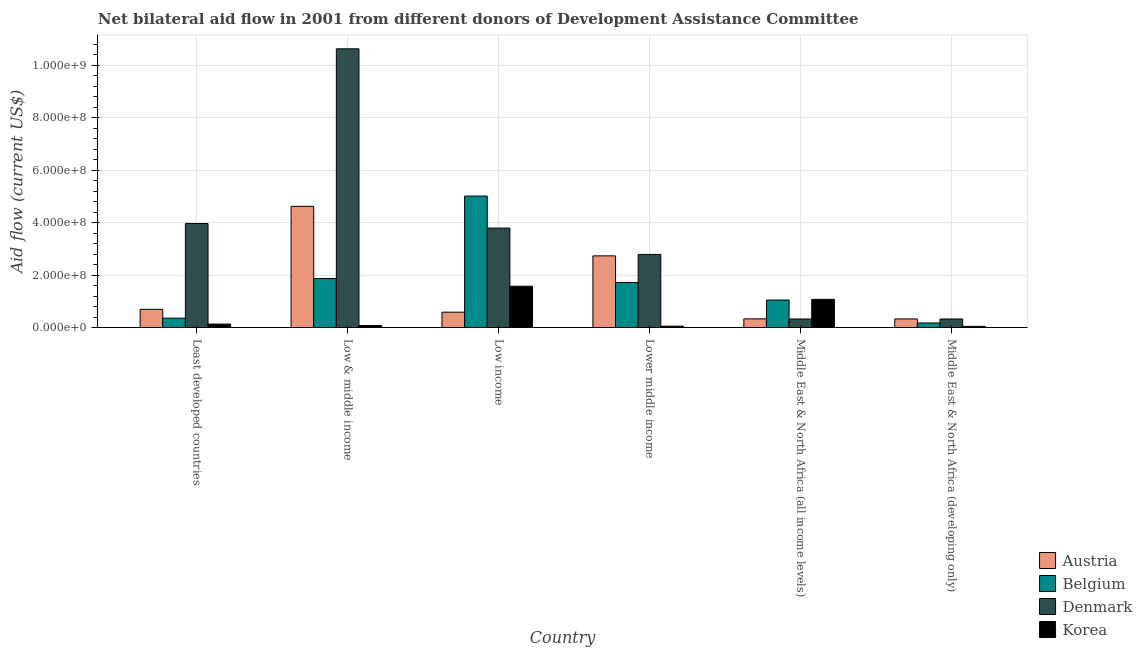How many different coloured bars are there?
Offer a very short reply. 4. How many groups of bars are there?
Your response must be concise. 6. Are the number of bars per tick equal to the number of legend labels?
Offer a terse response. Yes. How many bars are there on the 4th tick from the right?
Provide a succinct answer. 4. What is the label of the 6th group of bars from the left?
Offer a terse response. Middle East & North Africa (developing only). What is the amount of aid given by austria in Low income?
Provide a short and direct response. 5.91e+07. Across all countries, what is the maximum amount of aid given by denmark?
Ensure brevity in your answer.  1.06e+09. Across all countries, what is the minimum amount of aid given by belgium?
Your response must be concise. 1.79e+07. In which country was the amount of aid given by austria maximum?
Provide a succinct answer. Low & middle income. In which country was the amount of aid given by denmark minimum?
Give a very brief answer. Middle East & North Africa (all income levels). What is the total amount of aid given by belgium in the graph?
Your answer should be compact. 1.02e+09. What is the difference between the amount of aid given by korea in Least developed countries and that in Middle East & North Africa (all income levels)?
Provide a short and direct response. -9.42e+07. What is the difference between the amount of aid given by korea in Lower middle income and the amount of aid given by denmark in Least developed countries?
Your response must be concise. -3.91e+08. What is the average amount of aid given by austria per country?
Offer a terse response. 1.55e+08. What is the difference between the amount of aid given by denmark and amount of aid given by austria in Middle East & North Africa (all income levels)?
Ensure brevity in your answer.  -4.50e+05. In how many countries, is the amount of aid given by belgium greater than 40000000 US$?
Offer a terse response. 4. What is the ratio of the amount of aid given by austria in Least developed countries to that in Middle East & North Africa (developing only)?
Keep it short and to the point. 2.1. Is the difference between the amount of aid given by korea in Least developed countries and Middle East & North Africa (developing only) greater than the difference between the amount of aid given by belgium in Least developed countries and Middle East & North Africa (developing only)?
Give a very brief answer. No. What is the difference between the highest and the second highest amount of aid given by korea?
Your answer should be very brief. 5.00e+07. What is the difference between the highest and the lowest amount of aid given by belgium?
Your answer should be compact. 4.84e+08. Is it the case that in every country, the sum of the amount of aid given by korea and amount of aid given by denmark is greater than the sum of amount of aid given by austria and amount of aid given by belgium?
Offer a terse response. No. Are all the bars in the graph horizontal?
Ensure brevity in your answer.  No. How many countries are there in the graph?
Your answer should be compact. 6. What is the difference between two consecutive major ticks on the Y-axis?
Keep it short and to the point. 2.00e+08. Does the graph contain any zero values?
Ensure brevity in your answer.  No. Does the graph contain grids?
Provide a short and direct response. Yes. Where does the legend appear in the graph?
Give a very brief answer. Bottom right. How many legend labels are there?
Your answer should be compact. 4. How are the legend labels stacked?
Offer a terse response. Vertical. What is the title of the graph?
Your response must be concise. Net bilateral aid flow in 2001 from different donors of Development Assistance Committee. What is the label or title of the Y-axis?
Offer a terse response. Aid flow (current US$). What is the Aid flow (current US$) of Austria in Least developed countries?
Keep it short and to the point. 6.99e+07. What is the Aid flow (current US$) of Belgium in Least developed countries?
Your response must be concise. 3.63e+07. What is the Aid flow (current US$) of Denmark in Least developed countries?
Provide a short and direct response. 3.97e+08. What is the Aid flow (current US$) in Korea in Least developed countries?
Your answer should be very brief. 1.37e+07. What is the Aid flow (current US$) of Austria in Low & middle income?
Keep it short and to the point. 4.62e+08. What is the Aid flow (current US$) of Belgium in Low & middle income?
Ensure brevity in your answer.  1.87e+08. What is the Aid flow (current US$) in Denmark in Low & middle income?
Make the answer very short. 1.06e+09. What is the Aid flow (current US$) of Korea in Low & middle income?
Your answer should be very brief. 8.23e+06. What is the Aid flow (current US$) of Austria in Low income?
Keep it short and to the point. 5.91e+07. What is the Aid flow (current US$) of Belgium in Low income?
Ensure brevity in your answer.  5.02e+08. What is the Aid flow (current US$) of Denmark in Low income?
Keep it short and to the point. 3.80e+08. What is the Aid flow (current US$) of Korea in Low income?
Keep it short and to the point. 1.58e+08. What is the Aid flow (current US$) of Austria in Lower middle income?
Your answer should be compact. 2.74e+08. What is the Aid flow (current US$) in Belgium in Lower middle income?
Your response must be concise. 1.72e+08. What is the Aid flow (current US$) in Denmark in Lower middle income?
Offer a very short reply. 2.79e+08. What is the Aid flow (current US$) of Korea in Lower middle income?
Provide a succinct answer. 5.68e+06. What is the Aid flow (current US$) of Austria in Middle East & North Africa (all income levels)?
Your response must be concise. 3.35e+07. What is the Aid flow (current US$) in Belgium in Middle East & North Africa (all income levels)?
Make the answer very short. 1.05e+08. What is the Aid flow (current US$) of Denmark in Middle East & North Africa (all income levels)?
Keep it short and to the point. 3.31e+07. What is the Aid flow (current US$) in Korea in Middle East & North Africa (all income levels)?
Give a very brief answer. 1.08e+08. What is the Aid flow (current US$) of Austria in Middle East & North Africa (developing only)?
Give a very brief answer. 3.33e+07. What is the Aid flow (current US$) in Belgium in Middle East & North Africa (developing only)?
Make the answer very short. 1.79e+07. What is the Aid flow (current US$) of Denmark in Middle East & North Africa (developing only)?
Your answer should be very brief. 3.31e+07. What is the Aid flow (current US$) of Korea in Middle East & North Africa (developing only)?
Provide a succinct answer. 4.88e+06. Across all countries, what is the maximum Aid flow (current US$) of Austria?
Ensure brevity in your answer.  4.62e+08. Across all countries, what is the maximum Aid flow (current US$) in Belgium?
Provide a succinct answer. 5.02e+08. Across all countries, what is the maximum Aid flow (current US$) of Denmark?
Your answer should be very brief. 1.06e+09. Across all countries, what is the maximum Aid flow (current US$) in Korea?
Ensure brevity in your answer.  1.58e+08. Across all countries, what is the minimum Aid flow (current US$) of Austria?
Give a very brief answer. 3.33e+07. Across all countries, what is the minimum Aid flow (current US$) in Belgium?
Your answer should be compact. 1.79e+07. Across all countries, what is the minimum Aid flow (current US$) in Denmark?
Make the answer very short. 3.31e+07. Across all countries, what is the minimum Aid flow (current US$) in Korea?
Give a very brief answer. 4.88e+06. What is the total Aid flow (current US$) in Austria in the graph?
Keep it short and to the point. 9.32e+08. What is the total Aid flow (current US$) of Belgium in the graph?
Keep it short and to the point. 1.02e+09. What is the total Aid flow (current US$) in Denmark in the graph?
Keep it short and to the point. 2.18e+09. What is the total Aid flow (current US$) of Korea in the graph?
Your response must be concise. 2.98e+08. What is the difference between the Aid flow (current US$) of Austria in Least developed countries and that in Low & middle income?
Offer a terse response. -3.93e+08. What is the difference between the Aid flow (current US$) in Belgium in Least developed countries and that in Low & middle income?
Provide a succinct answer. -1.51e+08. What is the difference between the Aid flow (current US$) in Denmark in Least developed countries and that in Low & middle income?
Make the answer very short. -6.66e+08. What is the difference between the Aid flow (current US$) of Korea in Least developed countries and that in Low & middle income?
Your answer should be very brief. 5.43e+06. What is the difference between the Aid flow (current US$) of Austria in Least developed countries and that in Low income?
Make the answer very short. 1.08e+07. What is the difference between the Aid flow (current US$) of Belgium in Least developed countries and that in Low income?
Ensure brevity in your answer.  -4.65e+08. What is the difference between the Aid flow (current US$) in Denmark in Least developed countries and that in Low income?
Make the answer very short. 1.73e+07. What is the difference between the Aid flow (current US$) of Korea in Least developed countries and that in Low income?
Keep it short and to the point. -1.44e+08. What is the difference between the Aid flow (current US$) of Austria in Least developed countries and that in Lower middle income?
Provide a succinct answer. -2.04e+08. What is the difference between the Aid flow (current US$) in Belgium in Least developed countries and that in Lower middle income?
Your answer should be compact. -1.36e+08. What is the difference between the Aid flow (current US$) in Denmark in Least developed countries and that in Lower middle income?
Ensure brevity in your answer.  1.18e+08. What is the difference between the Aid flow (current US$) of Korea in Least developed countries and that in Lower middle income?
Make the answer very short. 7.98e+06. What is the difference between the Aid flow (current US$) of Austria in Least developed countries and that in Middle East & North Africa (all income levels)?
Provide a short and direct response. 3.64e+07. What is the difference between the Aid flow (current US$) in Belgium in Least developed countries and that in Middle East & North Africa (all income levels)?
Make the answer very short. -6.90e+07. What is the difference between the Aid flow (current US$) of Denmark in Least developed countries and that in Middle East & North Africa (all income levels)?
Your answer should be compact. 3.64e+08. What is the difference between the Aid flow (current US$) in Korea in Least developed countries and that in Middle East & North Africa (all income levels)?
Your response must be concise. -9.42e+07. What is the difference between the Aid flow (current US$) of Austria in Least developed countries and that in Middle East & North Africa (developing only)?
Your answer should be very brief. 3.66e+07. What is the difference between the Aid flow (current US$) of Belgium in Least developed countries and that in Middle East & North Africa (developing only)?
Give a very brief answer. 1.84e+07. What is the difference between the Aid flow (current US$) in Denmark in Least developed countries and that in Middle East & North Africa (developing only)?
Provide a succinct answer. 3.64e+08. What is the difference between the Aid flow (current US$) of Korea in Least developed countries and that in Middle East & North Africa (developing only)?
Offer a terse response. 8.78e+06. What is the difference between the Aid flow (current US$) of Austria in Low & middle income and that in Low income?
Give a very brief answer. 4.03e+08. What is the difference between the Aid flow (current US$) of Belgium in Low & middle income and that in Low income?
Give a very brief answer. -3.14e+08. What is the difference between the Aid flow (current US$) in Denmark in Low & middle income and that in Low income?
Provide a short and direct response. 6.83e+08. What is the difference between the Aid flow (current US$) in Korea in Low & middle income and that in Low income?
Offer a terse response. -1.50e+08. What is the difference between the Aid flow (current US$) of Austria in Low & middle income and that in Lower middle income?
Your response must be concise. 1.89e+08. What is the difference between the Aid flow (current US$) of Belgium in Low & middle income and that in Lower middle income?
Make the answer very short. 1.51e+07. What is the difference between the Aid flow (current US$) of Denmark in Low & middle income and that in Lower middle income?
Provide a short and direct response. 7.84e+08. What is the difference between the Aid flow (current US$) of Korea in Low & middle income and that in Lower middle income?
Offer a very short reply. 2.55e+06. What is the difference between the Aid flow (current US$) of Austria in Low & middle income and that in Middle East & North Africa (all income levels)?
Provide a short and direct response. 4.29e+08. What is the difference between the Aid flow (current US$) of Belgium in Low & middle income and that in Middle East & North Africa (all income levels)?
Make the answer very short. 8.21e+07. What is the difference between the Aid flow (current US$) of Denmark in Low & middle income and that in Middle East & North Africa (all income levels)?
Keep it short and to the point. 1.03e+09. What is the difference between the Aid flow (current US$) of Korea in Low & middle income and that in Middle East & North Africa (all income levels)?
Make the answer very short. -9.96e+07. What is the difference between the Aid flow (current US$) in Austria in Low & middle income and that in Middle East & North Africa (developing only)?
Your answer should be very brief. 4.29e+08. What is the difference between the Aid flow (current US$) in Belgium in Low & middle income and that in Middle East & North Africa (developing only)?
Your response must be concise. 1.69e+08. What is the difference between the Aid flow (current US$) in Denmark in Low & middle income and that in Middle East & North Africa (developing only)?
Keep it short and to the point. 1.03e+09. What is the difference between the Aid flow (current US$) of Korea in Low & middle income and that in Middle East & North Africa (developing only)?
Offer a terse response. 3.35e+06. What is the difference between the Aid flow (current US$) of Austria in Low income and that in Lower middle income?
Your response must be concise. -2.15e+08. What is the difference between the Aid flow (current US$) of Belgium in Low income and that in Lower middle income?
Provide a succinct answer. 3.29e+08. What is the difference between the Aid flow (current US$) of Denmark in Low income and that in Lower middle income?
Make the answer very short. 1.01e+08. What is the difference between the Aid flow (current US$) in Korea in Low income and that in Lower middle income?
Your answer should be compact. 1.52e+08. What is the difference between the Aid flow (current US$) in Austria in Low income and that in Middle East & North Africa (all income levels)?
Ensure brevity in your answer.  2.56e+07. What is the difference between the Aid flow (current US$) in Belgium in Low income and that in Middle East & North Africa (all income levels)?
Give a very brief answer. 3.96e+08. What is the difference between the Aid flow (current US$) in Denmark in Low income and that in Middle East & North Africa (all income levels)?
Offer a very short reply. 3.47e+08. What is the difference between the Aid flow (current US$) of Korea in Low income and that in Middle East & North Africa (all income levels)?
Provide a short and direct response. 5.00e+07. What is the difference between the Aid flow (current US$) of Austria in Low income and that in Middle East & North Africa (developing only)?
Offer a very short reply. 2.58e+07. What is the difference between the Aid flow (current US$) in Belgium in Low income and that in Middle East & North Africa (developing only)?
Ensure brevity in your answer.  4.84e+08. What is the difference between the Aid flow (current US$) in Denmark in Low income and that in Middle East & North Africa (developing only)?
Keep it short and to the point. 3.47e+08. What is the difference between the Aid flow (current US$) of Korea in Low income and that in Middle East & North Africa (developing only)?
Offer a terse response. 1.53e+08. What is the difference between the Aid flow (current US$) in Austria in Lower middle income and that in Middle East & North Africa (all income levels)?
Make the answer very short. 2.40e+08. What is the difference between the Aid flow (current US$) in Belgium in Lower middle income and that in Middle East & North Africa (all income levels)?
Your response must be concise. 6.70e+07. What is the difference between the Aid flow (current US$) in Denmark in Lower middle income and that in Middle East & North Africa (all income levels)?
Your answer should be compact. 2.46e+08. What is the difference between the Aid flow (current US$) of Korea in Lower middle income and that in Middle East & North Africa (all income levels)?
Ensure brevity in your answer.  -1.02e+08. What is the difference between the Aid flow (current US$) of Austria in Lower middle income and that in Middle East & North Africa (developing only)?
Offer a terse response. 2.40e+08. What is the difference between the Aid flow (current US$) in Belgium in Lower middle income and that in Middle East & North Africa (developing only)?
Your answer should be compact. 1.54e+08. What is the difference between the Aid flow (current US$) of Denmark in Lower middle income and that in Middle East & North Africa (developing only)?
Provide a succinct answer. 2.46e+08. What is the difference between the Aid flow (current US$) of Korea in Lower middle income and that in Middle East & North Africa (developing only)?
Offer a very short reply. 8.00e+05. What is the difference between the Aid flow (current US$) in Belgium in Middle East & North Africa (all income levels) and that in Middle East & North Africa (developing only)?
Provide a short and direct response. 8.74e+07. What is the difference between the Aid flow (current US$) of Korea in Middle East & North Africa (all income levels) and that in Middle East & North Africa (developing only)?
Ensure brevity in your answer.  1.03e+08. What is the difference between the Aid flow (current US$) of Austria in Least developed countries and the Aid flow (current US$) of Belgium in Low & middle income?
Provide a succinct answer. -1.18e+08. What is the difference between the Aid flow (current US$) of Austria in Least developed countries and the Aid flow (current US$) of Denmark in Low & middle income?
Make the answer very short. -9.93e+08. What is the difference between the Aid flow (current US$) in Austria in Least developed countries and the Aid flow (current US$) in Korea in Low & middle income?
Offer a very short reply. 6.17e+07. What is the difference between the Aid flow (current US$) of Belgium in Least developed countries and the Aid flow (current US$) of Denmark in Low & middle income?
Ensure brevity in your answer.  -1.03e+09. What is the difference between the Aid flow (current US$) of Belgium in Least developed countries and the Aid flow (current US$) of Korea in Low & middle income?
Offer a terse response. 2.81e+07. What is the difference between the Aid flow (current US$) in Denmark in Least developed countries and the Aid flow (current US$) in Korea in Low & middle income?
Offer a very short reply. 3.89e+08. What is the difference between the Aid flow (current US$) in Austria in Least developed countries and the Aid flow (current US$) in Belgium in Low income?
Offer a terse response. -4.32e+08. What is the difference between the Aid flow (current US$) of Austria in Least developed countries and the Aid flow (current US$) of Denmark in Low income?
Offer a very short reply. -3.10e+08. What is the difference between the Aid flow (current US$) in Austria in Least developed countries and the Aid flow (current US$) in Korea in Low income?
Your answer should be compact. -8.80e+07. What is the difference between the Aid flow (current US$) of Belgium in Least developed countries and the Aid flow (current US$) of Denmark in Low income?
Provide a succinct answer. -3.43e+08. What is the difference between the Aid flow (current US$) in Belgium in Least developed countries and the Aid flow (current US$) in Korea in Low income?
Make the answer very short. -1.22e+08. What is the difference between the Aid flow (current US$) in Denmark in Least developed countries and the Aid flow (current US$) in Korea in Low income?
Provide a short and direct response. 2.39e+08. What is the difference between the Aid flow (current US$) of Austria in Least developed countries and the Aid flow (current US$) of Belgium in Lower middle income?
Make the answer very short. -1.02e+08. What is the difference between the Aid flow (current US$) in Austria in Least developed countries and the Aid flow (current US$) in Denmark in Lower middle income?
Your answer should be very brief. -2.09e+08. What is the difference between the Aid flow (current US$) of Austria in Least developed countries and the Aid flow (current US$) of Korea in Lower middle income?
Provide a succinct answer. 6.42e+07. What is the difference between the Aid flow (current US$) of Belgium in Least developed countries and the Aid flow (current US$) of Denmark in Lower middle income?
Give a very brief answer. -2.43e+08. What is the difference between the Aid flow (current US$) of Belgium in Least developed countries and the Aid flow (current US$) of Korea in Lower middle income?
Provide a short and direct response. 3.07e+07. What is the difference between the Aid flow (current US$) in Denmark in Least developed countries and the Aid flow (current US$) in Korea in Lower middle income?
Keep it short and to the point. 3.91e+08. What is the difference between the Aid flow (current US$) in Austria in Least developed countries and the Aid flow (current US$) in Belgium in Middle East & North Africa (all income levels)?
Offer a very short reply. -3.54e+07. What is the difference between the Aid flow (current US$) in Austria in Least developed countries and the Aid flow (current US$) in Denmark in Middle East & North Africa (all income levels)?
Your answer should be compact. 3.68e+07. What is the difference between the Aid flow (current US$) in Austria in Least developed countries and the Aid flow (current US$) in Korea in Middle East & North Africa (all income levels)?
Provide a short and direct response. -3.80e+07. What is the difference between the Aid flow (current US$) of Belgium in Least developed countries and the Aid flow (current US$) of Denmark in Middle East & North Africa (all income levels)?
Offer a very short reply. 3.28e+06. What is the difference between the Aid flow (current US$) in Belgium in Least developed countries and the Aid flow (current US$) in Korea in Middle East & North Africa (all income levels)?
Give a very brief answer. -7.15e+07. What is the difference between the Aid flow (current US$) of Denmark in Least developed countries and the Aid flow (current US$) of Korea in Middle East & North Africa (all income levels)?
Provide a succinct answer. 2.89e+08. What is the difference between the Aid flow (current US$) of Austria in Least developed countries and the Aid flow (current US$) of Belgium in Middle East & North Africa (developing only)?
Keep it short and to the point. 5.20e+07. What is the difference between the Aid flow (current US$) of Austria in Least developed countries and the Aid flow (current US$) of Denmark in Middle East & North Africa (developing only)?
Your answer should be compact. 3.68e+07. What is the difference between the Aid flow (current US$) of Austria in Least developed countries and the Aid flow (current US$) of Korea in Middle East & North Africa (developing only)?
Make the answer very short. 6.50e+07. What is the difference between the Aid flow (current US$) of Belgium in Least developed countries and the Aid flow (current US$) of Denmark in Middle East & North Africa (developing only)?
Make the answer very short. 3.28e+06. What is the difference between the Aid flow (current US$) in Belgium in Least developed countries and the Aid flow (current US$) in Korea in Middle East & North Africa (developing only)?
Your answer should be very brief. 3.15e+07. What is the difference between the Aid flow (current US$) of Denmark in Least developed countries and the Aid flow (current US$) of Korea in Middle East & North Africa (developing only)?
Offer a very short reply. 3.92e+08. What is the difference between the Aid flow (current US$) in Austria in Low & middle income and the Aid flow (current US$) in Belgium in Low income?
Provide a succinct answer. -3.92e+07. What is the difference between the Aid flow (current US$) of Austria in Low & middle income and the Aid flow (current US$) of Denmark in Low income?
Provide a succinct answer. 8.28e+07. What is the difference between the Aid flow (current US$) in Austria in Low & middle income and the Aid flow (current US$) in Korea in Low income?
Make the answer very short. 3.04e+08. What is the difference between the Aid flow (current US$) in Belgium in Low & middle income and the Aid flow (current US$) in Denmark in Low income?
Offer a very short reply. -1.92e+08. What is the difference between the Aid flow (current US$) in Belgium in Low & middle income and the Aid flow (current US$) in Korea in Low income?
Your answer should be compact. 2.95e+07. What is the difference between the Aid flow (current US$) of Denmark in Low & middle income and the Aid flow (current US$) of Korea in Low income?
Provide a short and direct response. 9.05e+08. What is the difference between the Aid flow (current US$) in Austria in Low & middle income and the Aid flow (current US$) in Belgium in Lower middle income?
Your response must be concise. 2.90e+08. What is the difference between the Aid flow (current US$) of Austria in Low & middle income and the Aid flow (current US$) of Denmark in Lower middle income?
Make the answer very short. 1.83e+08. What is the difference between the Aid flow (current US$) in Austria in Low & middle income and the Aid flow (current US$) in Korea in Lower middle income?
Keep it short and to the point. 4.57e+08. What is the difference between the Aid flow (current US$) of Belgium in Low & middle income and the Aid flow (current US$) of Denmark in Lower middle income?
Keep it short and to the point. -9.16e+07. What is the difference between the Aid flow (current US$) in Belgium in Low & middle income and the Aid flow (current US$) in Korea in Lower middle income?
Ensure brevity in your answer.  1.82e+08. What is the difference between the Aid flow (current US$) of Denmark in Low & middle income and the Aid flow (current US$) of Korea in Lower middle income?
Offer a very short reply. 1.06e+09. What is the difference between the Aid flow (current US$) in Austria in Low & middle income and the Aid flow (current US$) in Belgium in Middle East & North Africa (all income levels)?
Your answer should be very brief. 3.57e+08. What is the difference between the Aid flow (current US$) of Austria in Low & middle income and the Aid flow (current US$) of Denmark in Middle East & North Africa (all income levels)?
Keep it short and to the point. 4.29e+08. What is the difference between the Aid flow (current US$) of Austria in Low & middle income and the Aid flow (current US$) of Korea in Middle East & North Africa (all income levels)?
Provide a short and direct response. 3.55e+08. What is the difference between the Aid flow (current US$) of Belgium in Low & middle income and the Aid flow (current US$) of Denmark in Middle East & North Africa (all income levels)?
Provide a succinct answer. 1.54e+08. What is the difference between the Aid flow (current US$) in Belgium in Low & middle income and the Aid flow (current US$) in Korea in Middle East & North Africa (all income levels)?
Your response must be concise. 7.95e+07. What is the difference between the Aid flow (current US$) in Denmark in Low & middle income and the Aid flow (current US$) in Korea in Middle East & North Africa (all income levels)?
Offer a very short reply. 9.55e+08. What is the difference between the Aid flow (current US$) of Austria in Low & middle income and the Aid flow (current US$) of Belgium in Middle East & North Africa (developing only)?
Keep it short and to the point. 4.44e+08. What is the difference between the Aid flow (current US$) in Austria in Low & middle income and the Aid flow (current US$) in Denmark in Middle East & North Africa (developing only)?
Your answer should be compact. 4.29e+08. What is the difference between the Aid flow (current US$) of Austria in Low & middle income and the Aid flow (current US$) of Korea in Middle East & North Africa (developing only)?
Ensure brevity in your answer.  4.58e+08. What is the difference between the Aid flow (current US$) of Belgium in Low & middle income and the Aid flow (current US$) of Denmark in Middle East & North Africa (developing only)?
Offer a very short reply. 1.54e+08. What is the difference between the Aid flow (current US$) of Belgium in Low & middle income and the Aid flow (current US$) of Korea in Middle East & North Africa (developing only)?
Your response must be concise. 1.83e+08. What is the difference between the Aid flow (current US$) of Denmark in Low & middle income and the Aid flow (current US$) of Korea in Middle East & North Africa (developing only)?
Keep it short and to the point. 1.06e+09. What is the difference between the Aid flow (current US$) of Austria in Low income and the Aid flow (current US$) of Belgium in Lower middle income?
Give a very brief answer. -1.13e+08. What is the difference between the Aid flow (current US$) of Austria in Low income and the Aid flow (current US$) of Denmark in Lower middle income?
Give a very brief answer. -2.20e+08. What is the difference between the Aid flow (current US$) of Austria in Low income and the Aid flow (current US$) of Korea in Lower middle income?
Your answer should be very brief. 5.34e+07. What is the difference between the Aid flow (current US$) of Belgium in Low income and the Aid flow (current US$) of Denmark in Lower middle income?
Make the answer very short. 2.23e+08. What is the difference between the Aid flow (current US$) in Belgium in Low income and the Aid flow (current US$) in Korea in Lower middle income?
Offer a very short reply. 4.96e+08. What is the difference between the Aid flow (current US$) of Denmark in Low income and the Aid flow (current US$) of Korea in Lower middle income?
Give a very brief answer. 3.74e+08. What is the difference between the Aid flow (current US$) of Austria in Low income and the Aid flow (current US$) of Belgium in Middle East & North Africa (all income levels)?
Offer a terse response. -4.62e+07. What is the difference between the Aid flow (current US$) in Austria in Low income and the Aid flow (current US$) in Denmark in Middle East & North Africa (all income levels)?
Ensure brevity in your answer.  2.60e+07. What is the difference between the Aid flow (current US$) of Austria in Low income and the Aid flow (current US$) of Korea in Middle East & North Africa (all income levels)?
Your answer should be compact. -4.88e+07. What is the difference between the Aid flow (current US$) of Belgium in Low income and the Aid flow (current US$) of Denmark in Middle East & North Africa (all income levels)?
Offer a terse response. 4.69e+08. What is the difference between the Aid flow (current US$) of Belgium in Low income and the Aid flow (current US$) of Korea in Middle East & North Africa (all income levels)?
Provide a short and direct response. 3.94e+08. What is the difference between the Aid flow (current US$) in Denmark in Low income and the Aid flow (current US$) in Korea in Middle East & North Africa (all income levels)?
Your response must be concise. 2.72e+08. What is the difference between the Aid flow (current US$) in Austria in Low income and the Aid flow (current US$) in Belgium in Middle East & North Africa (developing only)?
Keep it short and to the point. 4.12e+07. What is the difference between the Aid flow (current US$) in Austria in Low income and the Aid flow (current US$) in Denmark in Middle East & North Africa (developing only)?
Make the answer very short. 2.60e+07. What is the difference between the Aid flow (current US$) of Austria in Low income and the Aid flow (current US$) of Korea in Middle East & North Africa (developing only)?
Offer a very short reply. 5.42e+07. What is the difference between the Aid flow (current US$) in Belgium in Low income and the Aid flow (current US$) in Denmark in Middle East & North Africa (developing only)?
Your response must be concise. 4.69e+08. What is the difference between the Aid flow (current US$) in Belgium in Low income and the Aid flow (current US$) in Korea in Middle East & North Africa (developing only)?
Your answer should be compact. 4.97e+08. What is the difference between the Aid flow (current US$) in Denmark in Low income and the Aid flow (current US$) in Korea in Middle East & North Africa (developing only)?
Offer a very short reply. 3.75e+08. What is the difference between the Aid flow (current US$) of Austria in Lower middle income and the Aid flow (current US$) of Belgium in Middle East & North Africa (all income levels)?
Provide a short and direct response. 1.68e+08. What is the difference between the Aid flow (current US$) of Austria in Lower middle income and the Aid flow (current US$) of Denmark in Middle East & North Africa (all income levels)?
Your answer should be very brief. 2.41e+08. What is the difference between the Aid flow (current US$) in Austria in Lower middle income and the Aid flow (current US$) in Korea in Middle East & North Africa (all income levels)?
Your answer should be very brief. 1.66e+08. What is the difference between the Aid flow (current US$) of Belgium in Lower middle income and the Aid flow (current US$) of Denmark in Middle East & North Africa (all income levels)?
Provide a short and direct response. 1.39e+08. What is the difference between the Aid flow (current US$) in Belgium in Lower middle income and the Aid flow (current US$) in Korea in Middle East & North Africa (all income levels)?
Provide a short and direct response. 6.44e+07. What is the difference between the Aid flow (current US$) in Denmark in Lower middle income and the Aid flow (current US$) in Korea in Middle East & North Africa (all income levels)?
Your response must be concise. 1.71e+08. What is the difference between the Aid flow (current US$) in Austria in Lower middle income and the Aid flow (current US$) in Belgium in Middle East & North Africa (developing only)?
Your answer should be very brief. 2.56e+08. What is the difference between the Aid flow (current US$) of Austria in Lower middle income and the Aid flow (current US$) of Denmark in Middle East & North Africa (developing only)?
Offer a terse response. 2.41e+08. What is the difference between the Aid flow (current US$) of Austria in Lower middle income and the Aid flow (current US$) of Korea in Middle East & North Africa (developing only)?
Your answer should be very brief. 2.69e+08. What is the difference between the Aid flow (current US$) of Belgium in Lower middle income and the Aid flow (current US$) of Denmark in Middle East & North Africa (developing only)?
Your answer should be compact. 1.39e+08. What is the difference between the Aid flow (current US$) of Belgium in Lower middle income and the Aid flow (current US$) of Korea in Middle East & North Africa (developing only)?
Offer a terse response. 1.67e+08. What is the difference between the Aid flow (current US$) in Denmark in Lower middle income and the Aid flow (current US$) in Korea in Middle East & North Africa (developing only)?
Your answer should be very brief. 2.74e+08. What is the difference between the Aid flow (current US$) in Austria in Middle East & North Africa (all income levels) and the Aid flow (current US$) in Belgium in Middle East & North Africa (developing only)?
Make the answer very short. 1.56e+07. What is the difference between the Aid flow (current US$) in Austria in Middle East & North Africa (all income levels) and the Aid flow (current US$) in Korea in Middle East & North Africa (developing only)?
Keep it short and to the point. 2.86e+07. What is the difference between the Aid flow (current US$) of Belgium in Middle East & North Africa (all income levels) and the Aid flow (current US$) of Denmark in Middle East & North Africa (developing only)?
Your response must be concise. 7.23e+07. What is the difference between the Aid flow (current US$) in Belgium in Middle East & North Africa (all income levels) and the Aid flow (current US$) in Korea in Middle East & North Africa (developing only)?
Offer a very short reply. 1.00e+08. What is the difference between the Aid flow (current US$) in Denmark in Middle East & North Africa (all income levels) and the Aid flow (current US$) in Korea in Middle East & North Africa (developing only)?
Give a very brief answer. 2.82e+07. What is the average Aid flow (current US$) in Austria per country?
Make the answer very short. 1.55e+08. What is the average Aid flow (current US$) in Belgium per country?
Make the answer very short. 1.70e+08. What is the average Aid flow (current US$) of Denmark per country?
Your answer should be compact. 3.64e+08. What is the average Aid flow (current US$) of Korea per country?
Your answer should be very brief. 4.97e+07. What is the difference between the Aid flow (current US$) of Austria and Aid flow (current US$) of Belgium in Least developed countries?
Offer a very short reply. 3.36e+07. What is the difference between the Aid flow (current US$) in Austria and Aid flow (current US$) in Denmark in Least developed countries?
Provide a short and direct response. -3.27e+08. What is the difference between the Aid flow (current US$) in Austria and Aid flow (current US$) in Korea in Least developed countries?
Provide a succinct answer. 5.62e+07. What is the difference between the Aid flow (current US$) in Belgium and Aid flow (current US$) in Denmark in Least developed countries?
Your answer should be compact. -3.61e+08. What is the difference between the Aid flow (current US$) of Belgium and Aid flow (current US$) of Korea in Least developed countries?
Offer a very short reply. 2.27e+07. What is the difference between the Aid flow (current US$) in Denmark and Aid flow (current US$) in Korea in Least developed countries?
Provide a short and direct response. 3.83e+08. What is the difference between the Aid flow (current US$) of Austria and Aid flow (current US$) of Belgium in Low & middle income?
Give a very brief answer. 2.75e+08. What is the difference between the Aid flow (current US$) of Austria and Aid flow (current US$) of Denmark in Low & middle income?
Ensure brevity in your answer.  -6.00e+08. What is the difference between the Aid flow (current US$) of Austria and Aid flow (current US$) of Korea in Low & middle income?
Make the answer very short. 4.54e+08. What is the difference between the Aid flow (current US$) of Belgium and Aid flow (current US$) of Denmark in Low & middle income?
Offer a terse response. -8.75e+08. What is the difference between the Aid flow (current US$) of Belgium and Aid flow (current US$) of Korea in Low & middle income?
Provide a short and direct response. 1.79e+08. What is the difference between the Aid flow (current US$) in Denmark and Aid flow (current US$) in Korea in Low & middle income?
Provide a short and direct response. 1.05e+09. What is the difference between the Aid flow (current US$) in Austria and Aid flow (current US$) in Belgium in Low income?
Offer a terse response. -4.43e+08. What is the difference between the Aid flow (current US$) of Austria and Aid flow (current US$) of Denmark in Low income?
Give a very brief answer. -3.20e+08. What is the difference between the Aid flow (current US$) of Austria and Aid flow (current US$) of Korea in Low income?
Offer a very short reply. -9.88e+07. What is the difference between the Aid flow (current US$) in Belgium and Aid flow (current US$) in Denmark in Low income?
Ensure brevity in your answer.  1.22e+08. What is the difference between the Aid flow (current US$) of Belgium and Aid flow (current US$) of Korea in Low income?
Your response must be concise. 3.44e+08. What is the difference between the Aid flow (current US$) in Denmark and Aid flow (current US$) in Korea in Low income?
Your answer should be very brief. 2.22e+08. What is the difference between the Aid flow (current US$) of Austria and Aid flow (current US$) of Belgium in Lower middle income?
Offer a terse response. 1.01e+08. What is the difference between the Aid flow (current US$) of Austria and Aid flow (current US$) of Denmark in Lower middle income?
Your response must be concise. -5.41e+06. What is the difference between the Aid flow (current US$) of Austria and Aid flow (current US$) of Korea in Lower middle income?
Offer a very short reply. 2.68e+08. What is the difference between the Aid flow (current US$) in Belgium and Aid flow (current US$) in Denmark in Lower middle income?
Ensure brevity in your answer.  -1.07e+08. What is the difference between the Aid flow (current US$) in Belgium and Aid flow (current US$) in Korea in Lower middle income?
Provide a short and direct response. 1.67e+08. What is the difference between the Aid flow (current US$) in Denmark and Aid flow (current US$) in Korea in Lower middle income?
Your answer should be very brief. 2.73e+08. What is the difference between the Aid flow (current US$) of Austria and Aid flow (current US$) of Belgium in Middle East & North Africa (all income levels)?
Your answer should be compact. -7.18e+07. What is the difference between the Aid flow (current US$) in Austria and Aid flow (current US$) in Denmark in Middle East & North Africa (all income levels)?
Offer a terse response. 4.50e+05. What is the difference between the Aid flow (current US$) of Austria and Aid flow (current US$) of Korea in Middle East & North Africa (all income levels)?
Your response must be concise. -7.44e+07. What is the difference between the Aid flow (current US$) of Belgium and Aid flow (current US$) of Denmark in Middle East & North Africa (all income levels)?
Provide a succinct answer. 7.23e+07. What is the difference between the Aid flow (current US$) of Belgium and Aid flow (current US$) of Korea in Middle East & North Africa (all income levels)?
Your answer should be compact. -2.56e+06. What is the difference between the Aid flow (current US$) of Denmark and Aid flow (current US$) of Korea in Middle East & North Africa (all income levels)?
Ensure brevity in your answer.  -7.48e+07. What is the difference between the Aid flow (current US$) in Austria and Aid flow (current US$) in Belgium in Middle East & North Africa (developing only)?
Give a very brief answer. 1.54e+07. What is the difference between the Aid flow (current US$) of Austria and Aid flow (current US$) of Korea in Middle East & North Africa (developing only)?
Provide a succinct answer. 2.84e+07. What is the difference between the Aid flow (current US$) of Belgium and Aid flow (current US$) of Denmark in Middle East & North Africa (developing only)?
Your response must be concise. -1.51e+07. What is the difference between the Aid flow (current US$) in Belgium and Aid flow (current US$) in Korea in Middle East & North Africa (developing only)?
Your response must be concise. 1.31e+07. What is the difference between the Aid flow (current US$) of Denmark and Aid flow (current US$) of Korea in Middle East & North Africa (developing only)?
Offer a very short reply. 2.82e+07. What is the ratio of the Aid flow (current US$) of Austria in Least developed countries to that in Low & middle income?
Make the answer very short. 0.15. What is the ratio of the Aid flow (current US$) of Belgium in Least developed countries to that in Low & middle income?
Your answer should be very brief. 0.19. What is the ratio of the Aid flow (current US$) in Denmark in Least developed countries to that in Low & middle income?
Make the answer very short. 0.37. What is the ratio of the Aid flow (current US$) in Korea in Least developed countries to that in Low & middle income?
Ensure brevity in your answer.  1.66. What is the ratio of the Aid flow (current US$) of Austria in Least developed countries to that in Low income?
Offer a very short reply. 1.18. What is the ratio of the Aid flow (current US$) of Belgium in Least developed countries to that in Low income?
Provide a short and direct response. 0.07. What is the ratio of the Aid flow (current US$) in Denmark in Least developed countries to that in Low income?
Provide a succinct answer. 1.05. What is the ratio of the Aid flow (current US$) in Korea in Least developed countries to that in Low income?
Make the answer very short. 0.09. What is the ratio of the Aid flow (current US$) in Austria in Least developed countries to that in Lower middle income?
Keep it short and to the point. 0.26. What is the ratio of the Aid flow (current US$) of Belgium in Least developed countries to that in Lower middle income?
Your response must be concise. 0.21. What is the ratio of the Aid flow (current US$) in Denmark in Least developed countries to that in Lower middle income?
Provide a succinct answer. 1.42. What is the ratio of the Aid flow (current US$) in Korea in Least developed countries to that in Lower middle income?
Provide a succinct answer. 2.4. What is the ratio of the Aid flow (current US$) of Austria in Least developed countries to that in Middle East & North Africa (all income levels)?
Give a very brief answer. 2.09. What is the ratio of the Aid flow (current US$) in Belgium in Least developed countries to that in Middle East & North Africa (all income levels)?
Give a very brief answer. 0.34. What is the ratio of the Aid flow (current US$) in Denmark in Least developed countries to that in Middle East & North Africa (all income levels)?
Provide a succinct answer. 12. What is the ratio of the Aid flow (current US$) of Korea in Least developed countries to that in Middle East & North Africa (all income levels)?
Your response must be concise. 0.13. What is the ratio of the Aid flow (current US$) in Austria in Least developed countries to that in Middle East & North Africa (developing only)?
Offer a very short reply. 2.1. What is the ratio of the Aid flow (current US$) in Belgium in Least developed countries to that in Middle East & North Africa (developing only)?
Ensure brevity in your answer.  2.03. What is the ratio of the Aid flow (current US$) in Denmark in Least developed countries to that in Middle East & North Africa (developing only)?
Keep it short and to the point. 12. What is the ratio of the Aid flow (current US$) of Korea in Least developed countries to that in Middle East & North Africa (developing only)?
Provide a short and direct response. 2.8. What is the ratio of the Aid flow (current US$) in Austria in Low & middle income to that in Low income?
Make the answer very short. 7.82. What is the ratio of the Aid flow (current US$) of Belgium in Low & middle income to that in Low income?
Ensure brevity in your answer.  0.37. What is the ratio of the Aid flow (current US$) in Denmark in Low & middle income to that in Low income?
Your answer should be very brief. 2.8. What is the ratio of the Aid flow (current US$) of Korea in Low & middle income to that in Low income?
Keep it short and to the point. 0.05. What is the ratio of the Aid flow (current US$) of Austria in Low & middle income to that in Lower middle income?
Ensure brevity in your answer.  1.69. What is the ratio of the Aid flow (current US$) in Belgium in Low & middle income to that in Lower middle income?
Your answer should be very brief. 1.09. What is the ratio of the Aid flow (current US$) in Denmark in Low & middle income to that in Lower middle income?
Give a very brief answer. 3.81. What is the ratio of the Aid flow (current US$) of Korea in Low & middle income to that in Lower middle income?
Make the answer very short. 1.45. What is the ratio of the Aid flow (current US$) in Austria in Low & middle income to that in Middle East & North Africa (all income levels)?
Make the answer very short. 13.8. What is the ratio of the Aid flow (current US$) in Belgium in Low & middle income to that in Middle East & North Africa (all income levels)?
Offer a terse response. 1.78. What is the ratio of the Aid flow (current US$) of Denmark in Low & middle income to that in Middle East & North Africa (all income levels)?
Ensure brevity in your answer.  32.15. What is the ratio of the Aid flow (current US$) in Korea in Low & middle income to that in Middle East & North Africa (all income levels)?
Offer a very short reply. 0.08. What is the ratio of the Aid flow (current US$) in Austria in Low & middle income to that in Middle East & North Africa (developing only)?
Ensure brevity in your answer.  13.89. What is the ratio of the Aid flow (current US$) of Belgium in Low & middle income to that in Middle East & North Africa (developing only)?
Your answer should be very brief. 10.45. What is the ratio of the Aid flow (current US$) of Denmark in Low & middle income to that in Middle East & North Africa (developing only)?
Your answer should be compact. 32.15. What is the ratio of the Aid flow (current US$) in Korea in Low & middle income to that in Middle East & North Africa (developing only)?
Offer a terse response. 1.69. What is the ratio of the Aid flow (current US$) of Austria in Low income to that in Lower middle income?
Your answer should be very brief. 0.22. What is the ratio of the Aid flow (current US$) of Belgium in Low income to that in Lower middle income?
Provide a succinct answer. 2.91. What is the ratio of the Aid flow (current US$) of Denmark in Low income to that in Lower middle income?
Provide a short and direct response. 1.36. What is the ratio of the Aid flow (current US$) of Korea in Low income to that in Lower middle income?
Your response must be concise. 27.8. What is the ratio of the Aid flow (current US$) of Austria in Low income to that in Middle East & North Africa (all income levels)?
Your response must be concise. 1.76. What is the ratio of the Aid flow (current US$) of Belgium in Low income to that in Middle East & North Africa (all income levels)?
Your answer should be compact. 4.76. What is the ratio of the Aid flow (current US$) in Denmark in Low income to that in Middle East & North Africa (all income levels)?
Offer a very short reply. 11.48. What is the ratio of the Aid flow (current US$) in Korea in Low income to that in Middle East & North Africa (all income levels)?
Offer a very short reply. 1.46. What is the ratio of the Aid flow (current US$) of Austria in Low income to that in Middle East & North Africa (developing only)?
Your response must be concise. 1.78. What is the ratio of the Aid flow (current US$) in Belgium in Low income to that in Middle East & North Africa (developing only)?
Your response must be concise. 27.96. What is the ratio of the Aid flow (current US$) in Denmark in Low income to that in Middle East & North Africa (developing only)?
Give a very brief answer. 11.48. What is the ratio of the Aid flow (current US$) in Korea in Low income to that in Middle East & North Africa (developing only)?
Give a very brief answer. 32.36. What is the ratio of the Aid flow (current US$) of Austria in Lower middle income to that in Middle East & North Africa (all income levels)?
Provide a succinct answer. 8.17. What is the ratio of the Aid flow (current US$) of Belgium in Lower middle income to that in Middle East & North Africa (all income levels)?
Ensure brevity in your answer.  1.64. What is the ratio of the Aid flow (current US$) of Denmark in Lower middle income to that in Middle East & North Africa (all income levels)?
Make the answer very short. 8.44. What is the ratio of the Aid flow (current US$) of Korea in Lower middle income to that in Middle East & North Africa (all income levels)?
Your answer should be very brief. 0.05. What is the ratio of the Aid flow (current US$) in Austria in Lower middle income to that in Middle East & North Africa (developing only)?
Your answer should be very brief. 8.22. What is the ratio of the Aid flow (current US$) in Belgium in Lower middle income to that in Middle East & North Africa (developing only)?
Your response must be concise. 9.6. What is the ratio of the Aid flow (current US$) in Denmark in Lower middle income to that in Middle East & North Africa (developing only)?
Offer a very short reply. 8.44. What is the ratio of the Aid flow (current US$) in Korea in Lower middle income to that in Middle East & North Africa (developing only)?
Ensure brevity in your answer.  1.16. What is the ratio of the Aid flow (current US$) of Austria in Middle East & North Africa (all income levels) to that in Middle East & North Africa (developing only)?
Ensure brevity in your answer.  1.01. What is the ratio of the Aid flow (current US$) in Belgium in Middle East & North Africa (all income levels) to that in Middle East & North Africa (developing only)?
Keep it short and to the point. 5.87. What is the ratio of the Aid flow (current US$) in Denmark in Middle East & North Africa (all income levels) to that in Middle East & North Africa (developing only)?
Your response must be concise. 1. What is the ratio of the Aid flow (current US$) in Korea in Middle East & North Africa (all income levels) to that in Middle East & North Africa (developing only)?
Your response must be concise. 22.11. What is the difference between the highest and the second highest Aid flow (current US$) of Austria?
Keep it short and to the point. 1.89e+08. What is the difference between the highest and the second highest Aid flow (current US$) in Belgium?
Your response must be concise. 3.14e+08. What is the difference between the highest and the second highest Aid flow (current US$) of Denmark?
Offer a terse response. 6.66e+08. What is the difference between the highest and the second highest Aid flow (current US$) in Korea?
Make the answer very short. 5.00e+07. What is the difference between the highest and the lowest Aid flow (current US$) in Austria?
Offer a terse response. 4.29e+08. What is the difference between the highest and the lowest Aid flow (current US$) in Belgium?
Make the answer very short. 4.84e+08. What is the difference between the highest and the lowest Aid flow (current US$) of Denmark?
Give a very brief answer. 1.03e+09. What is the difference between the highest and the lowest Aid flow (current US$) of Korea?
Your answer should be very brief. 1.53e+08. 